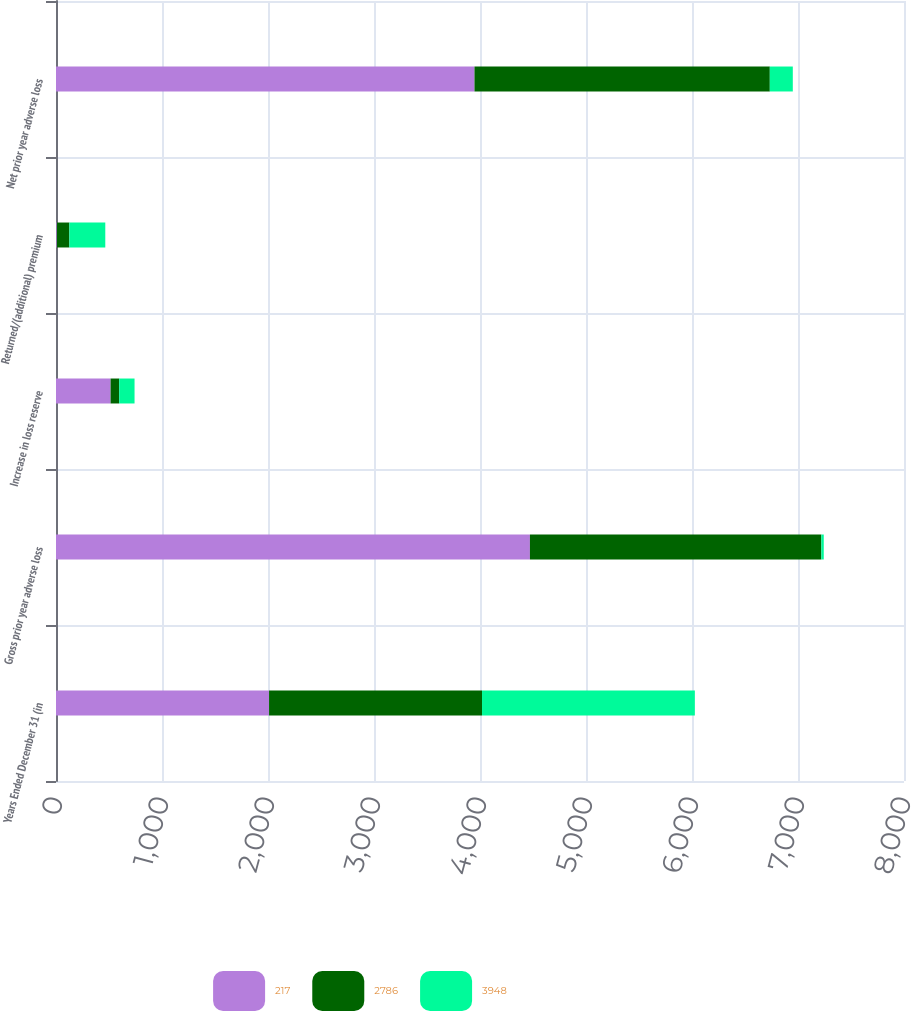<chart> <loc_0><loc_0><loc_500><loc_500><stacked_bar_chart><ecel><fcel>Years Ended December 31 (in<fcel>Gross prior year adverse loss<fcel>Increase in loss reserve<fcel>Returned/(additional) premium<fcel>Net prior year adverse loss<nl><fcel>217<fcel>2010<fcel>4471<fcel>515<fcel>8<fcel>3948<nl><fcel>2786<fcel>2009<fcel>2749<fcel>81<fcel>118<fcel>2786<nl><fcel>3948<fcel>2008<fcel>23<fcel>145<fcel>339<fcel>217<nl></chart> 